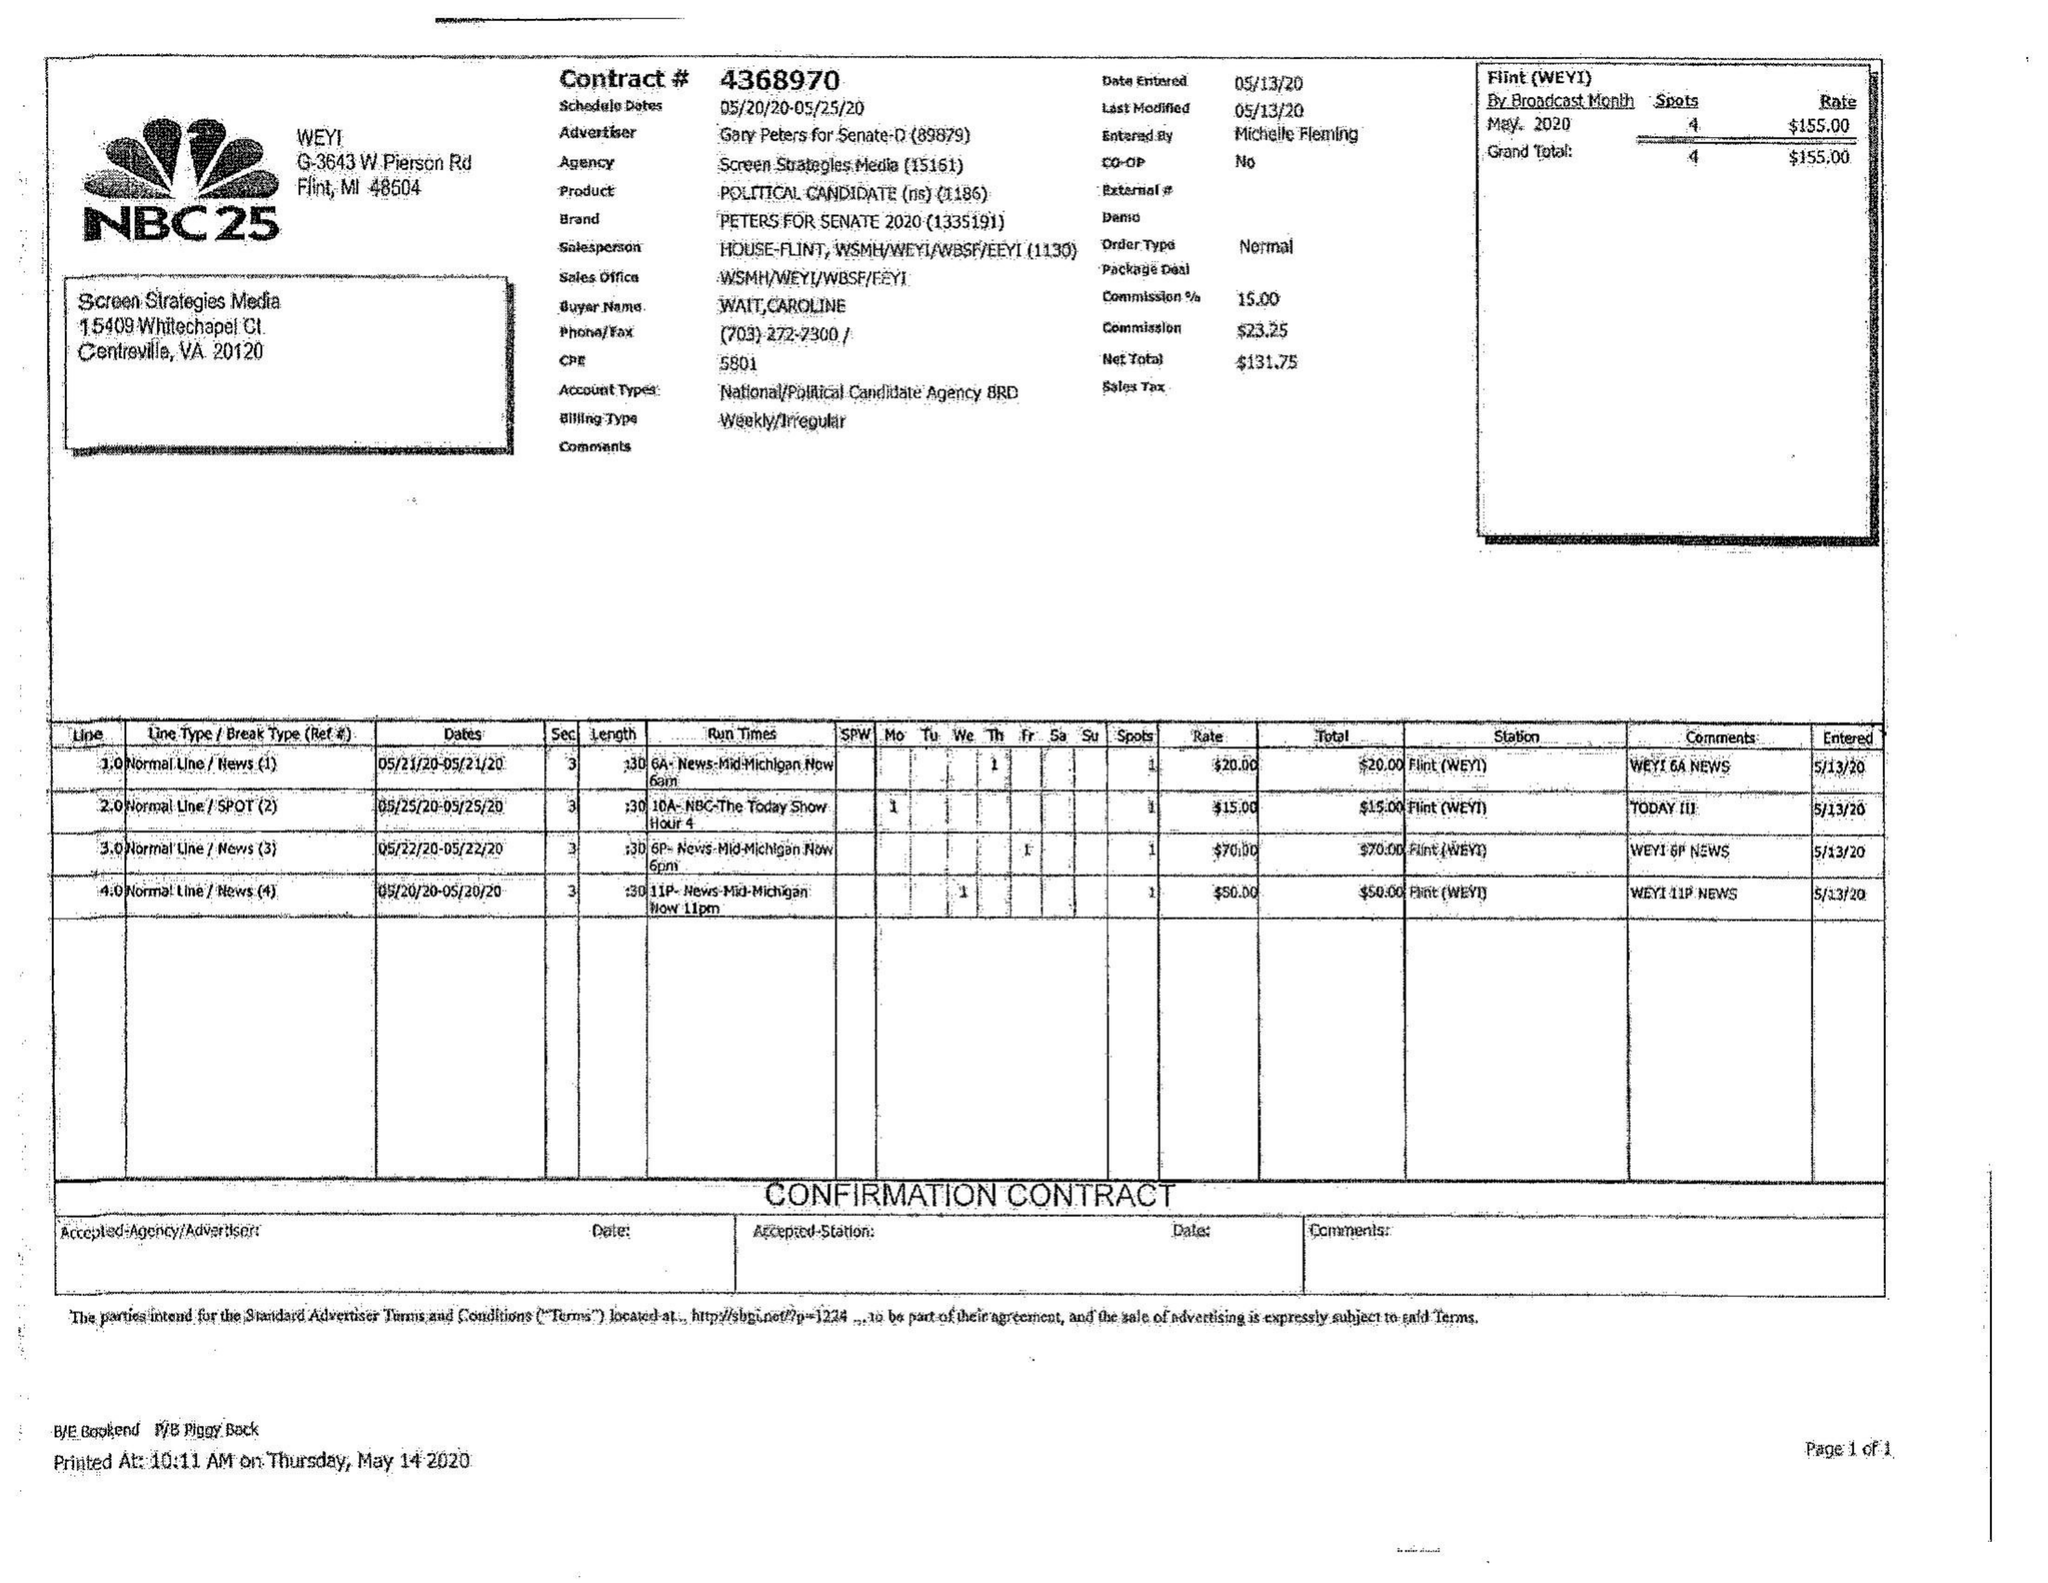What is the value for the contract_num?
Answer the question using a single word or phrase. 4368970 